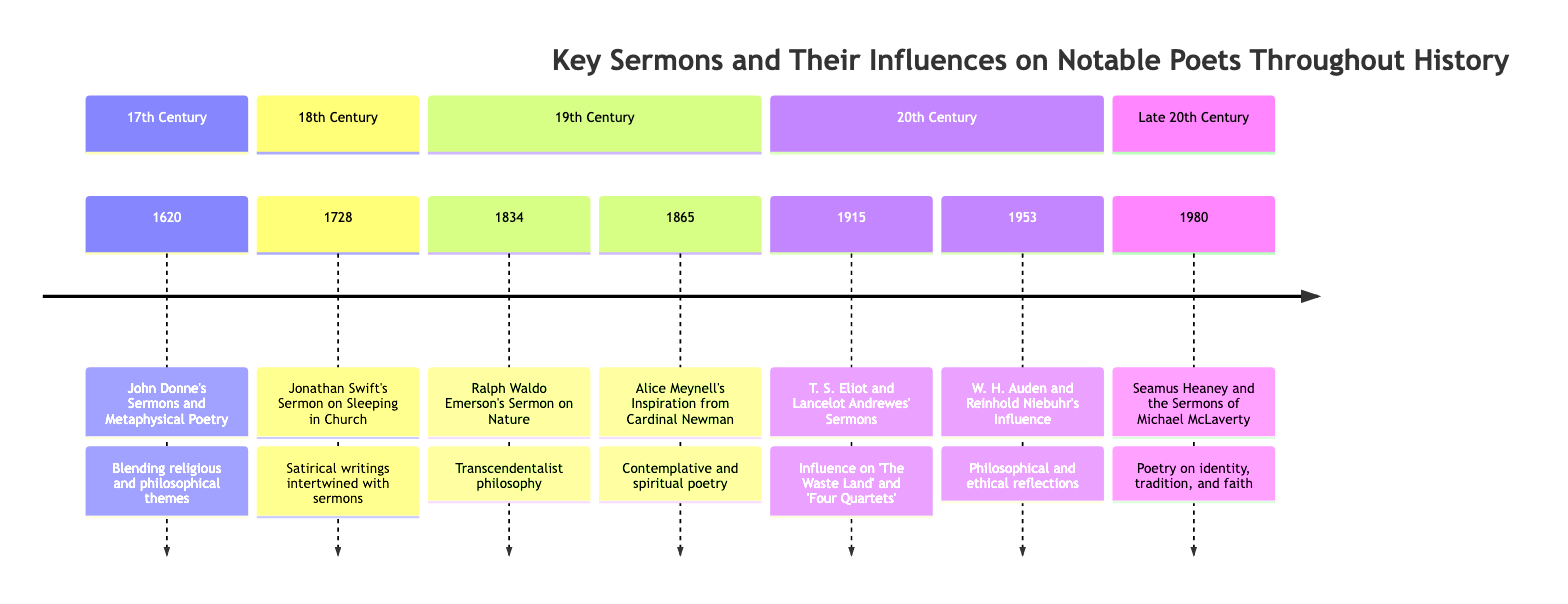What year did John Donne deliver his sermons? The diagram shows that John Donne's sermons were delivered in 1620, as indicated in the timeline element for that year.
Answer: 1620 What poet was influenced by Alice Meynell's inspiration from Cardinal Newman? According to the timeline, Alice Meynell was influenced by Cardinal Newman, but the timeline does not list a specific poet influenced directly by her; it shows her influence on her own poetry.
Answer: None How many key events are noted in the timeline? By counting the number of events listed under each section of the timeline, we can find that there are a total of seven key events presented, each corresponding to a notable poet and their influences.
Answer: 7 Which poet's work was influenced by Lancelot Andrewes' sermons? The timeline states that T. S. Eliot was influenced by the sermons of Lancelot Andrewes, which is noted in the entry for the year 1915.
Answer: T. S. Eliot What common theme connects Ralph Waldo Emerson's sermon and the works of the poets influenced by him? Emerson's sermon on Nature highlighted the transcendentalist philosophy, which connects to themes of nature, the divine, and individual soul explored further by poets influenced by similar ideas, reflecting deep connections to spirituality and existence.
Answer: Transcendentalism What is the primary influence on W. H. Auden's poetry, mentioned in the timeline? The timeline indicates that W. H. Auden was influenced by the sermons of Reinhold Niebuhr, which infused his poetry with philosophical and ethical reflections.
Answer: Reinhold Niebuhr In what year did Seamus Heaney draw inspiration from Michael McLaverty? The timeline clearly indicates that Seamus Heaney found inspiration in 1980 from the sermons of Michael McLaverty, as stated in the entry for that year.
Answer: 1980 Which poet's writings intertwined satire with religious themes in their sermons? The timeline specifies that Jonathan Swift’s sermons, including his noted work “Sleeping in Church”, intertwine satire with religious themes, highlighting his unique literary approach.
Answer: Jonathan Swift 